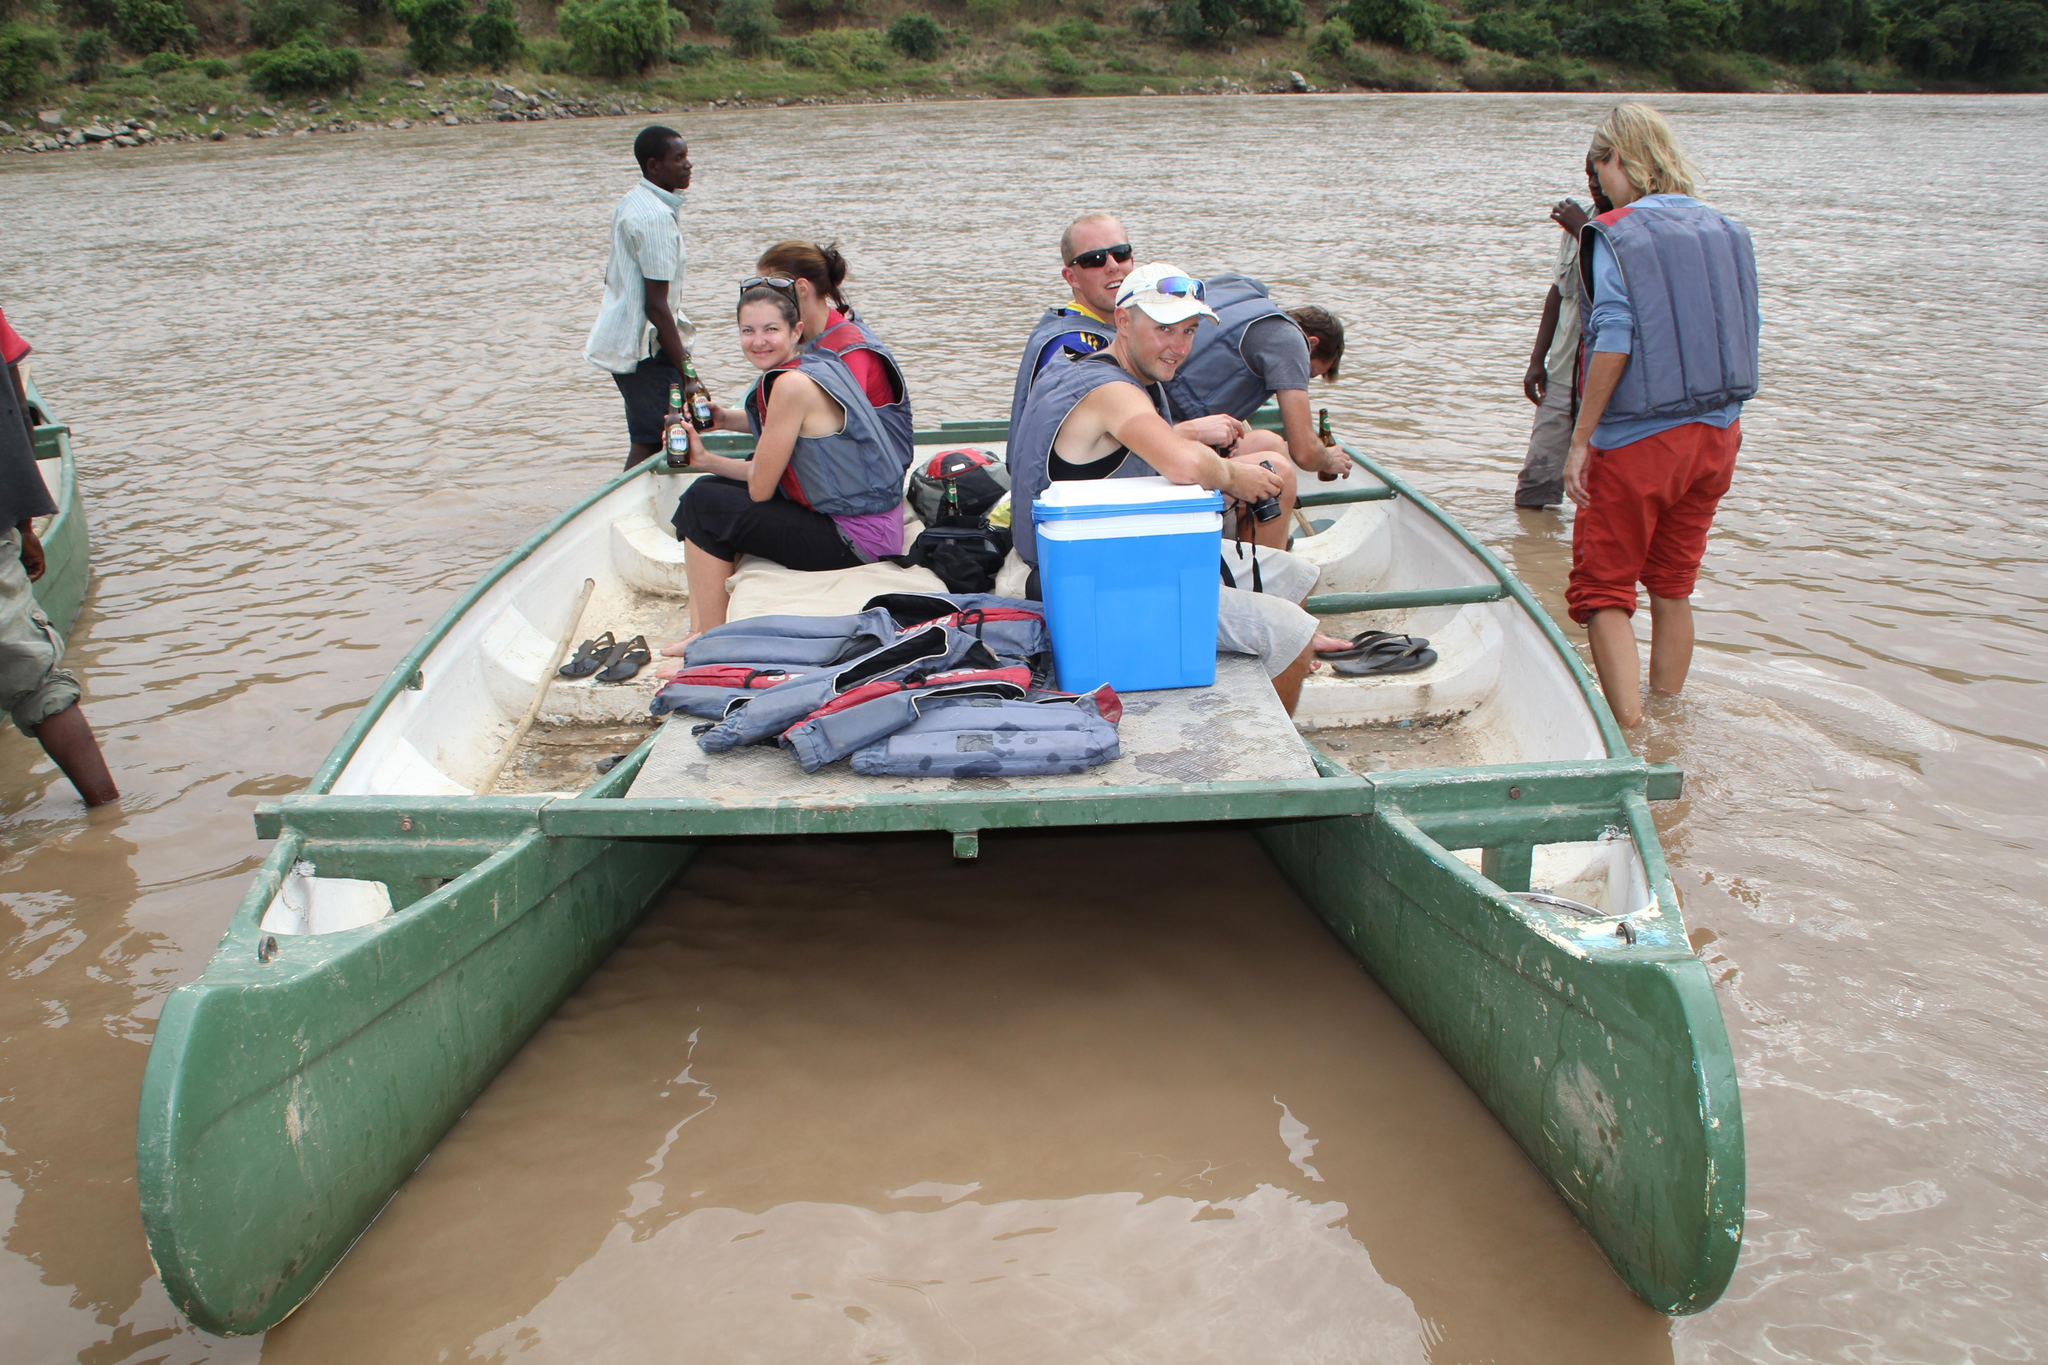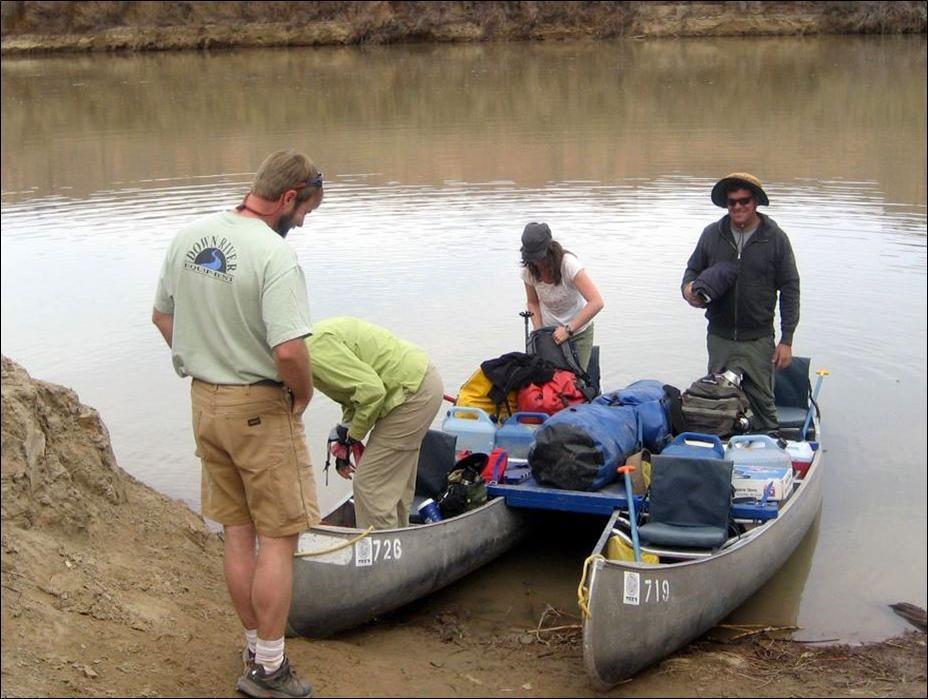The first image is the image on the left, the second image is the image on the right. Evaluate the accuracy of this statement regarding the images: "In each image, one or more persons is shown with a double canoe that is built with a solid flat platform between the two canoes.". Is it true? Answer yes or no. Yes. The first image is the image on the left, the second image is the image on the right. Given the left and right images, does the statement "There are at least half a dozen people in the boats." hold true? Answer yes or no. Yes. The first image is the image on the left, the second image is the image on the right. Analyze the images presented: Is the assertion "Both images show multiple people inside a double-rigger canoe that is at least partially on the water." valid? Answer yes or no. Yes. The first image is the image on the left, the second image is the image on the right. For the images shown, is this caption "There is an American flag on the boat in the image on the left." true? Answer yes or no. No. 